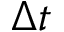Convert formula to latex. <formula><loc_0><loc_0><loc_500><loc_500>\Delta t</formula> 